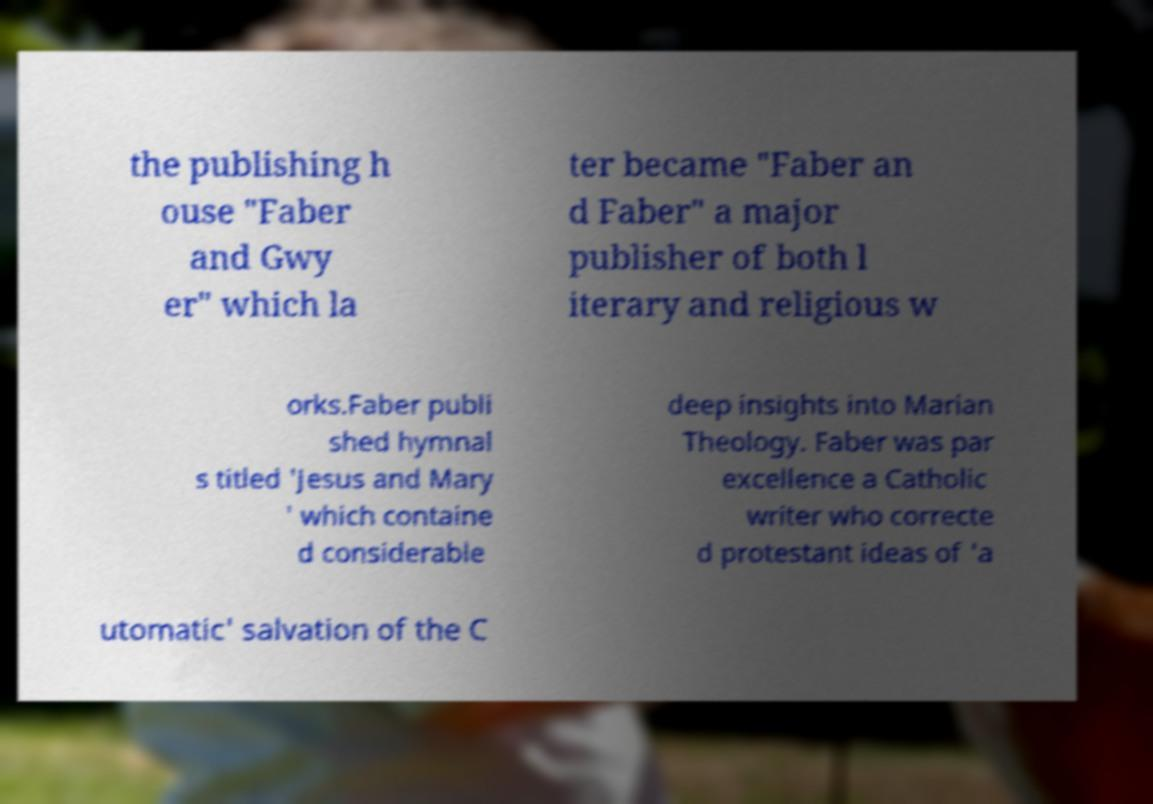I need the written content from this picture converted into text. Can you do that? the publishing h ouse "Faber and Gwy er" which la ter became "Faber an d Faber" a major publisher of both l iterary and religious w orks.Faber publi shed hymnal s titled 'Jesus and Mary ' which containe d considerable deep insights into Marian Theology. Faber was par excellence a Catholic writer who correcte d protestant ideas of 'a utomatic' salvation of the C 